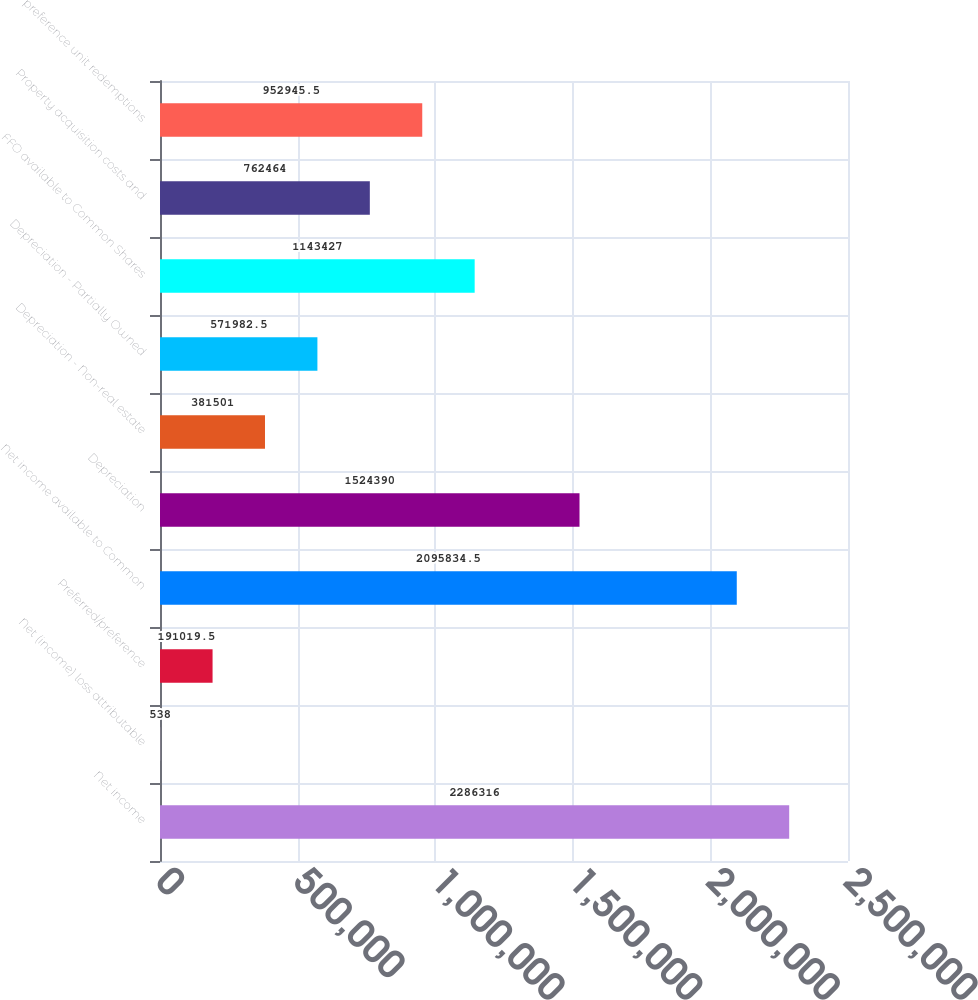<chart> <loc_0><loc_0><loc_500><loc_500><bar_chart><fcel>Net income<fcel>Net (income) loss attributable<fcel>Preferred/preference<fcel>Net income available to Common<fcel>Depreciation<fcel>Depreciation - Non-real estate<fcel>Depreciation - Partially Owned<fcel>FFO available to Common Shares<fcel>Property acquisition costs and<fcel>preference unit redemptions<nl><fcel>2.28632e+06<fcel>538<fcel>191020<fcel>2.09583e+06<fcel>1.52439e+06<fcel>381501<fcel>571982<fcel>1.14343e+06<fcel>762464<fcel>952946<nl></chart> 